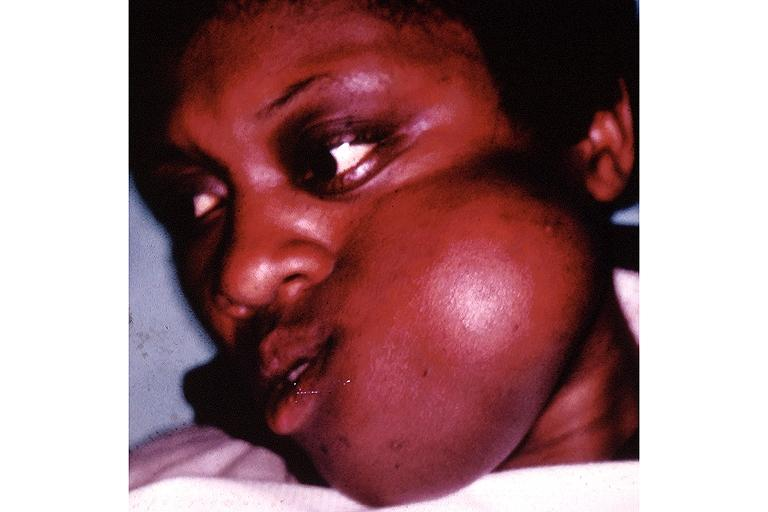s oral present?
Answer the question using a single word or phrase. Yes 